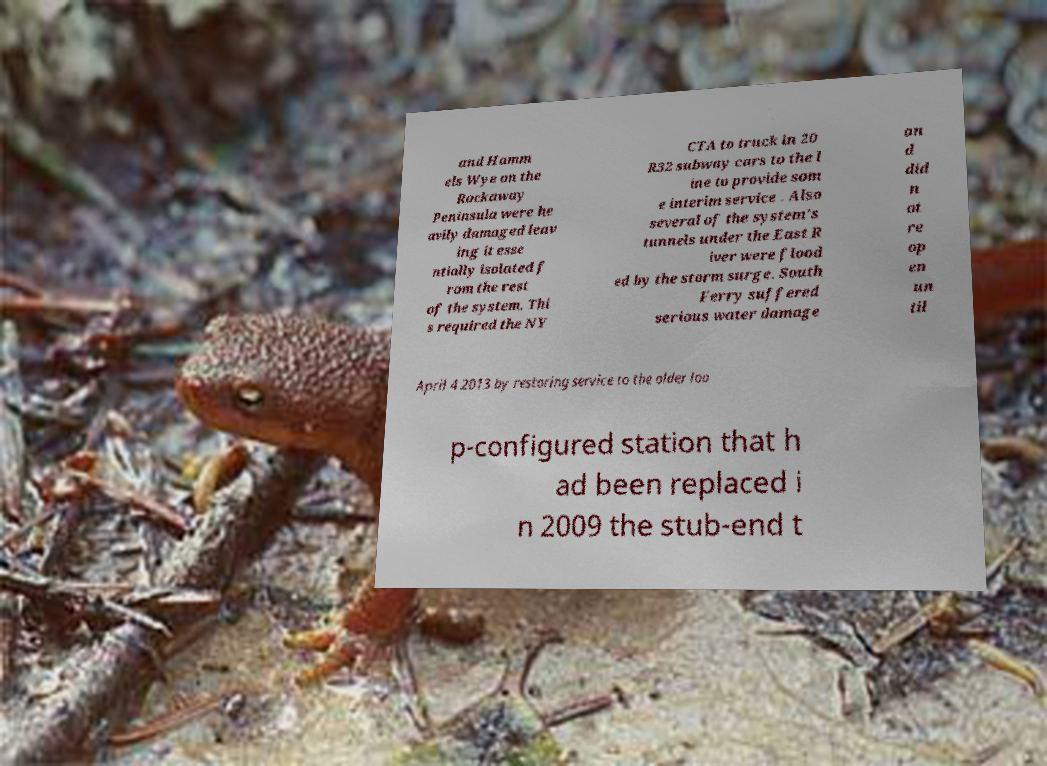Please identify and transcribe the text found in this image. and Hamm els Wye on the Rockaway Peninsula were he avily damaged leav ing it esse ntially isolated f rom the rest of the system. Thi s required the NY CTA to truck in 20 R32 subway cars to the l ine to provide som e interim service . Also several of the system's tunnels under the East R iver were flood ed by the storm surge. South Ferry suffered serious water damage an d did n ot re op en un til April 4 2013 by restoring service to the older loo p-configured station that h ad been replaced i n 2009 the stub-end t 